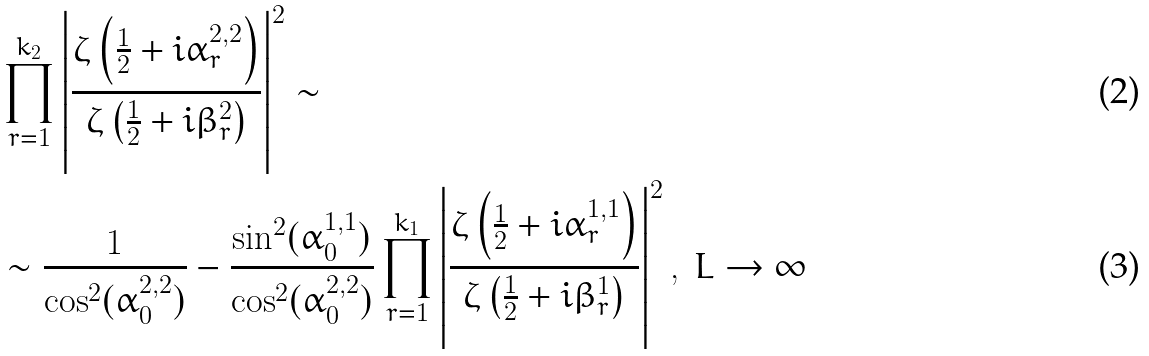<formula> <loc_0><loc_0><loc_500><loc_500>& \prod _ { r = 1 } ^ { k _ { 2 } } \left | \frac { \zeta \left ( \frac { 1 } { 2 } + i \alpha ^ { 2 , 2 } _ { r } \right ) } { \zeta \left ( \frac { 1 } { 2 } + i \beta _ { r } ^ { 2 } \right ) } \right | ^ { 2 } \sim \\ & \sim \frac { 1 } { \cos ^ { 2 } ( \alpha _ { 0 } ^ { 2 , 2 } ) } - \frac { \sin ^ { 2 } ( \alpha _ { 0 } ^ { 1 , 1 } ) } { \cos ^ { 2 } ( \alpha _ { 0 } ^ { 2 , 2 } ) } \prod _ { r = 1 } ^ { k _ { 1 } } \left | \frac { \zeta \left ( \frac { 1 } { 2 } + i \alpha ^ { 1 , 1 } _ { r } \right ) } { \zeta \left ( \frac { 1 } { 2 } + i \beta _ { r } ^ { 1 } \right ) } \right | ^ { 2 } , \ L \to \infty</formula> 